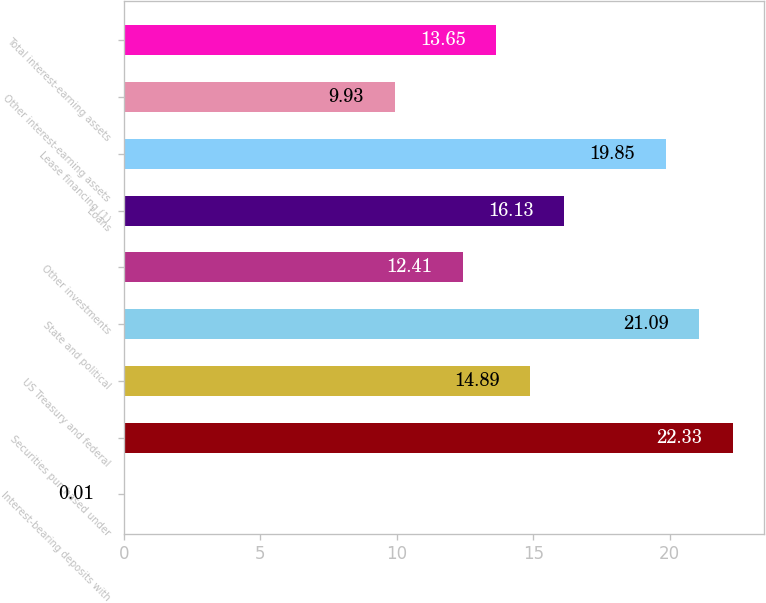Convert chart. <chart><loc_0><loc_0><loc_500><loc_500><bar_chart><fcel>Interest-bearing deposits with<fcel>Securities purchased under<fcel>US Treasury and federal<fcel>State and political<fcel>Other investments<fcel>Loans<fcel>Lease financing (1)<fcel>Other interest-earning assets<fcel>Total interest-earning assets<nl><fcel>0.01<fcel>22.33<fcel>14.89<fcel>21.09<fcel>12.41<fcel>16.13<fcel>19.85<fcel>9.93<fcel>13.65<nl></chart> 